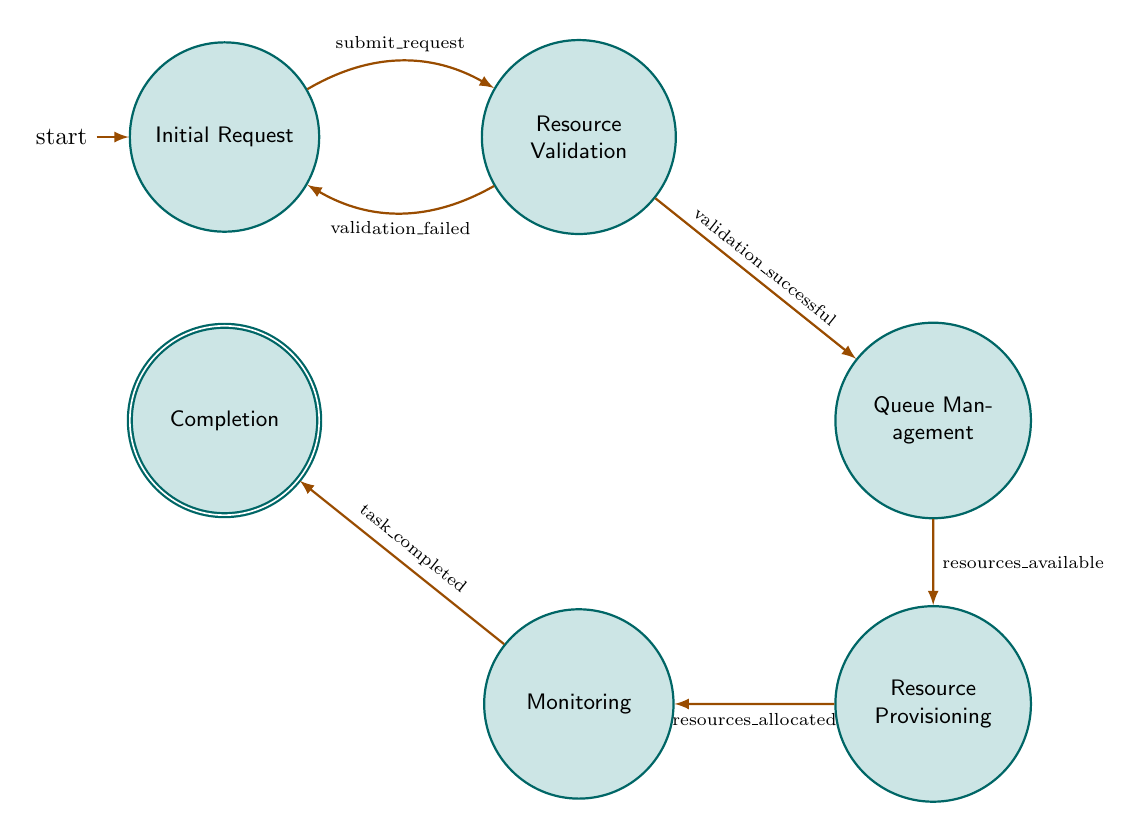What is the initial state of the diagram? The initial state of the diagram is labeled "Initial Request," which indicates where the flow begins in the finite state machine.
Answer: Initial Request How many states are present in the diagram? By counting the distinct labeled states in the diagram, we find there are six states: Initial Request, Resource Validation, Queue Management, Resource Provisioning, Monitoring, and Completion.
Answer: Six What happens after a successful validation? After a successful validation, the flow moves from the "Resource Validation" state to "Queue Management," indicating that the validated request is managed for further processing.
Answer: Queue Management What condition leads to the transition from "Initial Request" to "Resource Validation"? The transition from "Initial Request" to "Resource Validation" occurs under the condition labeled "submit_request," which represents the action taken by the researcher to initiate the request.
Answer: submit_request What is the final state of the process? The final state of the process, where the research task has concluded and resources are deallocated, is labeled "Completion." This indicates the end of the finite state machine's flow.
Answer: Completion What leads to the deallocation of resources? Resources are deallocated when the condition "task_completed" is met, indicating that the monitoring confirms the research task is finished and the resources can be released.
Answer: task_completed What is the only way to return to "Initial Request" from "Resource Validation"? The only way to return to "Initial Request" from "Resource Validation" is due to the condition labeled "validation_failed," indicating that the request did not pass validation.
Answer: validation_failed What ensures resource provisioning can occur? The transition to "Resource Provisioning" can only occur if the condition "resources_available" is satisfied, indicating that sufficient HPC resources are ready to be allocated.
Answer: resources_available How does the diagram illustrate the flow of resource allocation? The diagram illustrates the flow of resource allocation by showing directional arrows connecting various states based on actions and conditions, indicating the sequential progression from request through validation, management, provisioning, monitoring, and completion.
Answer: Sequential arrows 